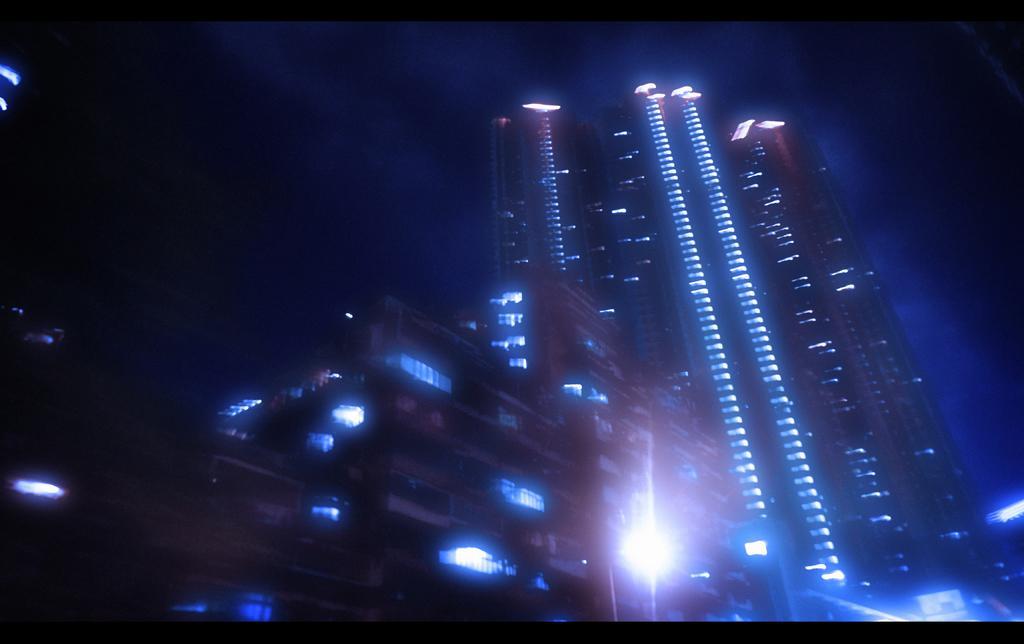Can you describe this image briefly? This image consists of skyscrapers and building. There are lights in the buildings. At the top, there is a sky. 